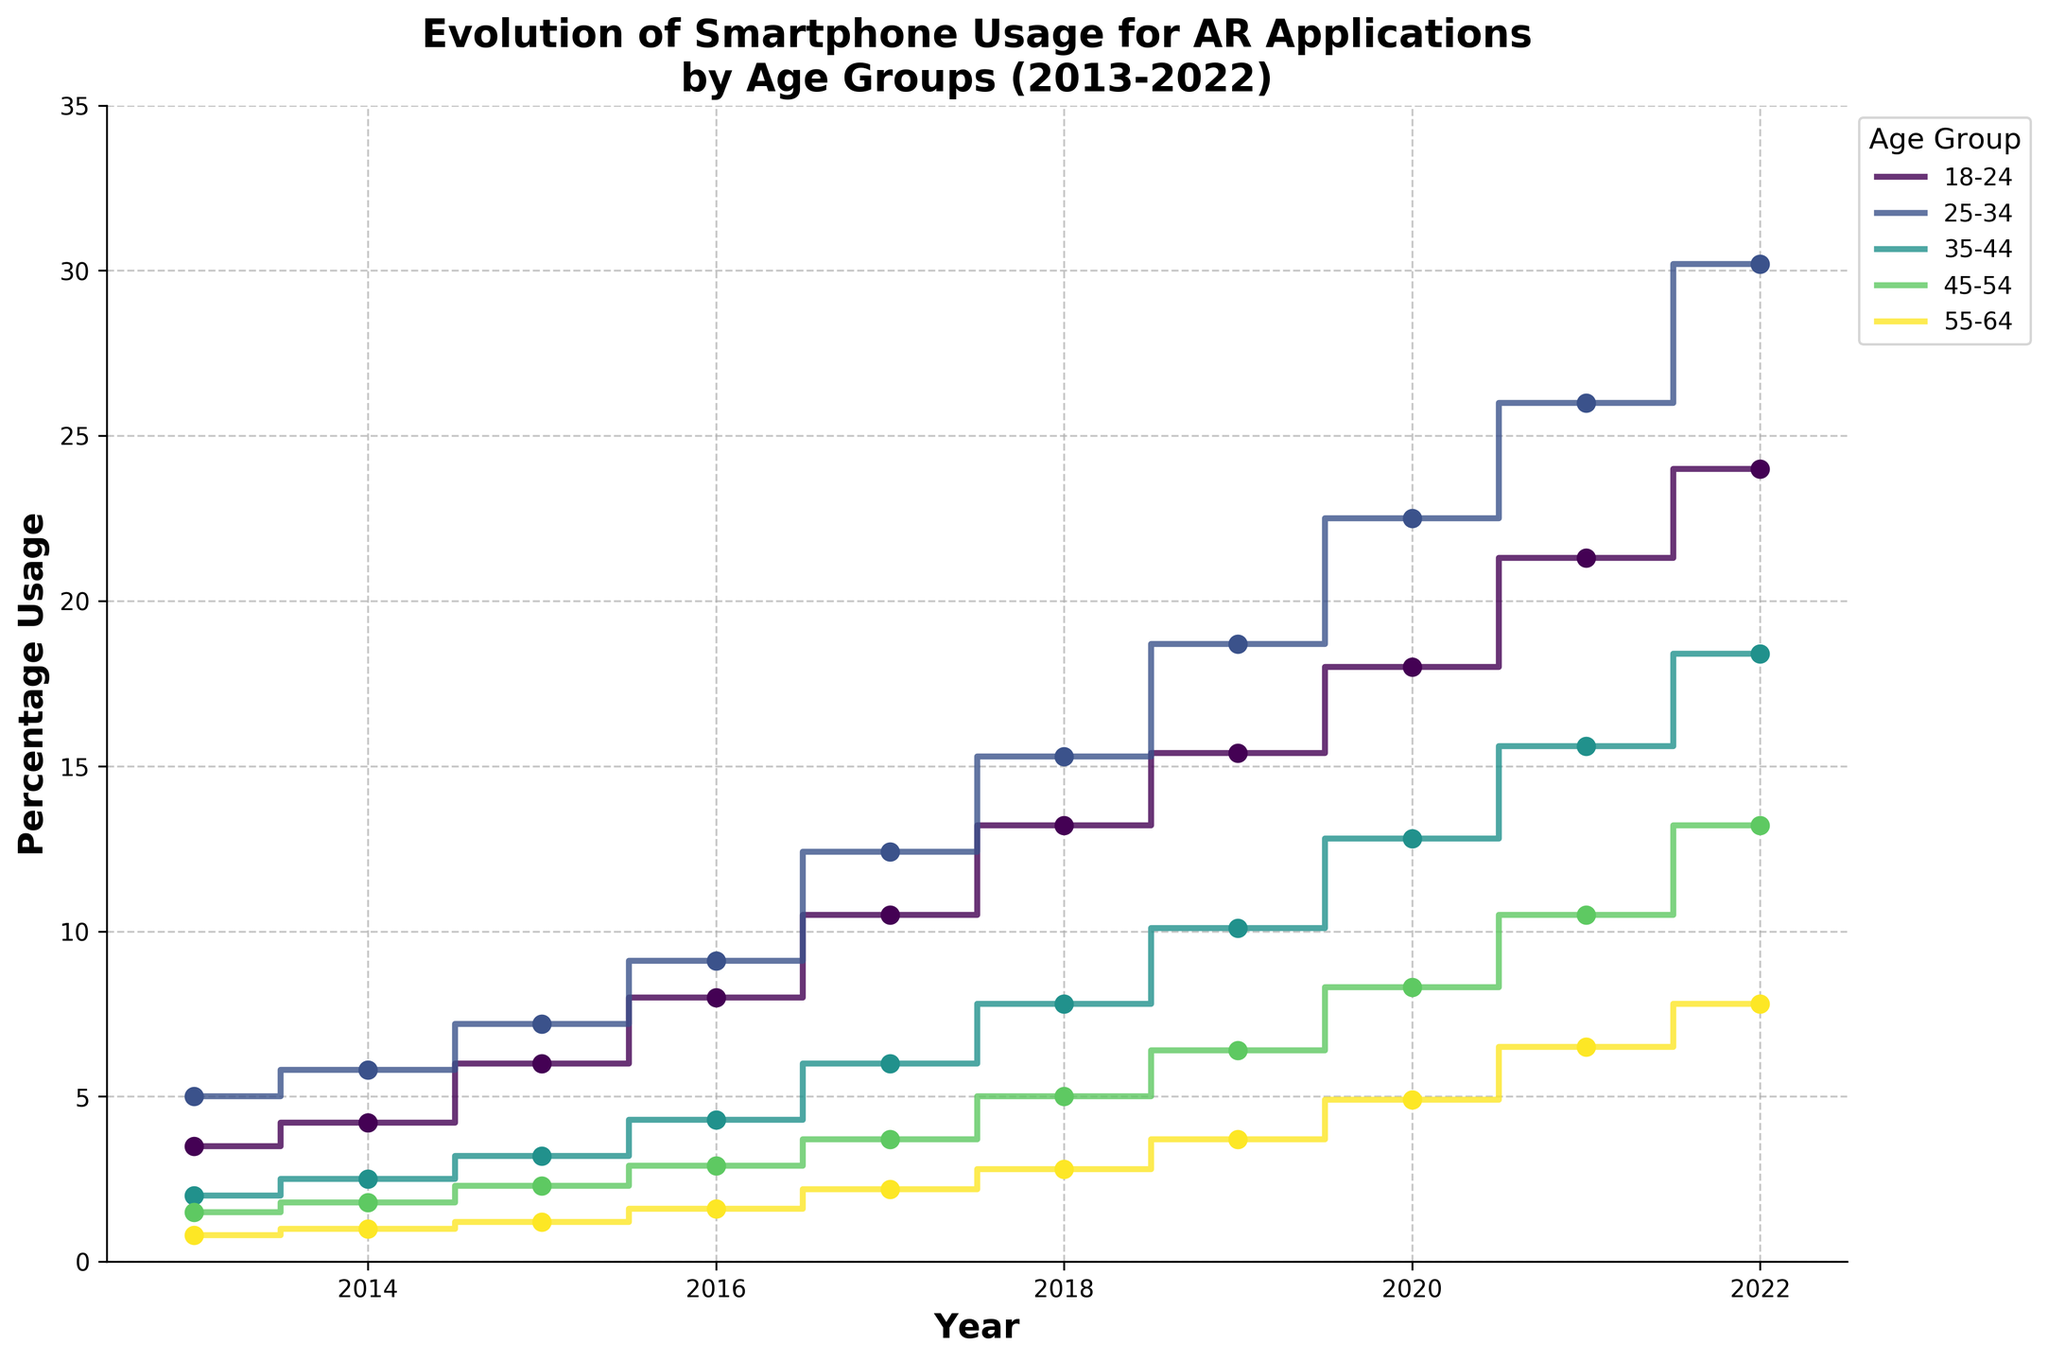What is the title of the figure? The title can be found at the top of the figure, which is usually clearly displayed and describes the content of the plot. In this case, the title is "Evolution of Smartphone Usage for AR Applications by Age Groups (2013-2022)".
Answer: Evolution of Smartphone Usage for AR Applications by Age Groups (2013-2022) What is the percentage usage of AR applications for the age group 25-34 in 2020? To find this, locate the year 2020 and then find the corresponding percentage usage value for the age group 25-34. The plot shows this percentage as 22.5%.
Answer: 22.5% In what year did the age group 55-64 exceed 5% usage of AR applications for the first time? To determine this, look at the data points for the age group 55-64 across the years. The plot shows that the first year they exceed 5% is in 2021.
Answer: 2021 Which age group had the highest percentage usage of AR applications in 2018? Review the data points for all age groups in the year 2018. The highest percentage of usage recorded for that year is by the age group 25-34 at 15.3%.
Answer: 25-34 Compare the percentage usage of AR applications for the age groups 18-24 and 35-44 in 2015. Which group has a higher usage and by how much? For 2015, the age group 18-24 has a usage of 6.0%, and the age group 35-44 has a usage of 3.2%. Calculate the difference by subtracting the lower percentage from the higher one: 6.0% - 3.2% = 2.8%.
Answer: 18-24 by 2.8% Determine the average percentage usage of AR applications for the age group 45-54 across the years shown in the plot. To find the average, sum the percentage values for the age group 45-54 across all years and divide by the number of years (10): (1.5 + 1.8 + 2.3 + 2.9 + 3.7 + 5.0 + 6.4 + 8.3 + 10.5 + 13.2) / 10 = 5.56%.
Answer: 5.56% Identify the age group with the most significant increase in AR application usage between 2013 and 2022. Calculate the increase for each age group by subtracting the 2013 value from the 2022 value. The age group 25-34 increased from 5.0% to 30.2%, indicating the most significant increase of 25.2%.
Answer: 25-34 What is the trend of AR application usage in the age group 18-24 over the past decade? Follow the trend line for the age group 18-24 from 2013 to 2022. It shows a consistent upward trend, indicating an increase in the usage of AR applications over the years.
Answer: Increasing trend In which year do all age groups show an upward spike in AR application usage compared to the previous year? Look at each year and compare the values for all age groups to the previous year. All age groups show a noticeable spike in 2017 compared to 2016.
Answer: 2017 